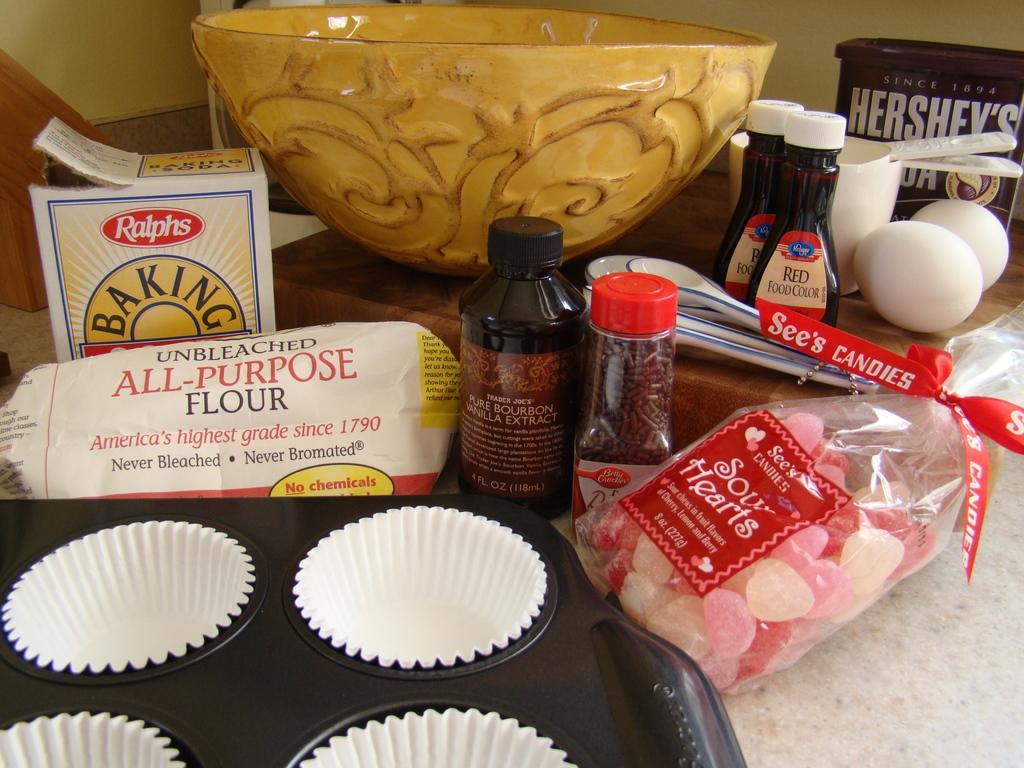Describe this image in one or two sentences. In the picture there is a mold of muffins,baking groceries,eggs,food color,Hershey's syrup and a bowl,all these are kept on the table. 